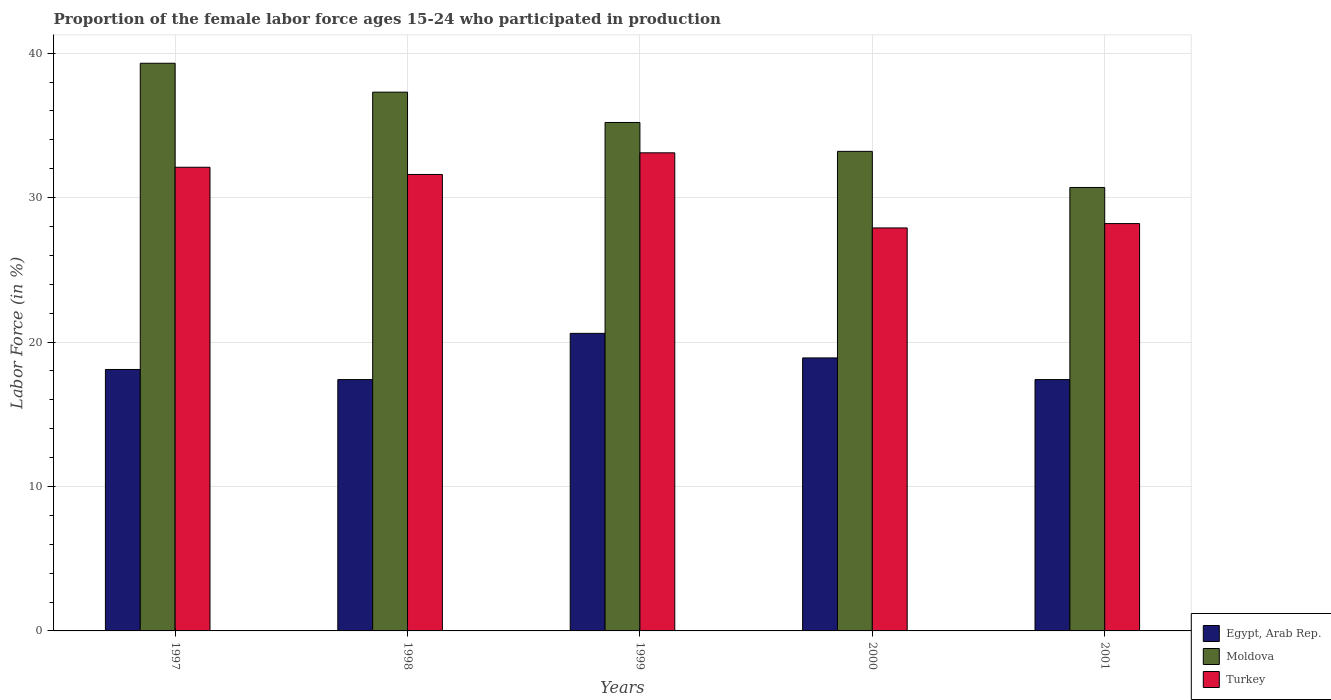How many different coloured bars are there?
Keep it short and to the point. 3. How many groups of bars are there?
Provide a short and direct response. 5. Are the number of bars per tick equal to the number of legend labels?
Your answer should be compact. Yes. How many bars are there on the 3rd tick from the right?
Your answer should be compact. 3. In how many cases, is the number of bars for a given year not equal to the number of legend labels?
Provide a short and direct response. 0. What is the proportion of the female labor force who participated in production in Egypt, Arab Rep. in 2001?
Keep it short and to the point. 17.4. Across all years, what is the maximum proportion of the female labor force who participated in production in Moldova?
Your response must be concise. 39.3. Across all years, what is the minimum proportion of the female labor force who participated in production in Turkey?
Provide a succinct answer. 27.9. In which year was the proportion of the female labor force who participated in production in Turkey maximum?
Offer a very short reply. 1999. What is the total proportion of the female labor force who participated in production in Egypt, Arab Rep. in the graph?
Ensure brevity in your answer.  92.4. What is the difference between the proportion of the female labor force who participated in production in Turkey in 1997 and that in 1998?
Give a very brief answer. 0.5. What is the difference between the proportion of the female labor force who participated in production in Moldova in 1998 and the proportion of the female labor force who participated in production in Turkey in 1999?
Offer a terse response. 4.2. What is the average proportion of the female labor force who participated in production in Moldova per year?
Your answer should be very brief. 35.14. In the year 1998, what is the difference between the proportion of the female labor force who participated in production in Moldova and proportion of the female labor force who participated in production in Egypt, Arab Rep.?
Offer a very short reply. 19.9. In how many years, is the proportion of the female labor force who participated in production in Egypt, Arab Rep. greater than 34 %?
Give a very brief answer. 0. What is the ratio of the proportion of the female labor force who participated in production in Moldova in 1998 to that in 1999?
Make the answer very short. 1.06. Is the difference between the proportion of the female labor force who participated in production in Moldova in 1999 and 2000 greater than the difference between the proportion of the female labor force who participated in production in Egypt, Arab Rep. in 1999 and 2000?
Provide a short and direct response. Yes. What is the difference between the highest and the second highest proportion of the female labor force who participated in production in Egypt, Arab Rep.?
Make the answer very short. 1.7. What is the difference between the highest and the lowest proportion of the female labor force who participated in production in Turkey?
Give a very brief answer. 5.2. In how many years, is the proportion of the female labor force who participated in production in Turkey greater than the average proportion of the female labor force who participated in production in Turkey taken over all years?
Provide a short and direct response. 3. Is the sum of the proportion of the female labor force who participated in production in Turkey in 1997 and 2001 greater than the maximum proportion of the female labor force who participated in production in Moldova across all years?
Provide a short and direct response. Yes. What does the 1st bar from the left in 1999 represents?
Offer a terse response. Egypt, Arab Rep. How many bars are there?
Your response must be concise. 15. What is the difference between two consecutive major ticks on the Y-axis?
Provide a short and direct response. 10. Are the values on the major ticks of Y-axis written in scientific E-notation?
Give a very brief answer. No. Does the graph contain any zero values?
Provide a succinct answer. No. What is the title of the graph?
Offer a very short reply. Proportion of the female labor force ages 15-24 who participated in production. Does "Japan" appear as one of the legend labels in the graph?
Provide a succinct answer. No. What is the label or title of the X-axis?
Offer a very short reply. Years. What is the Labor Force (in %) in Egypt, Arab Rep. in 1997?
Your answer should be very brief. 18.1. What is the Labor Force (in %) of Moldova in 1997?
Provide a short and direct response. 39.3. What is the Labor Force (in %) of Turkey in 1997?
Your response must be concise. 32.1. What is the Labor Force (in %) in Egypt, Arab Rep. in 1998?
Your answer should be compact. 17.4. What is the Labor Force (in %) of Moldova in 1998?
Make the answer very short. 37.3. What is the Labor Force (in %) in Turkey in 1998?
Ensure brevity in your answer.  31.6. What is the Labor Force (in %) of Egypt, Arab Rep. in 1999?
Provide a short and direct response. 20.6. What is the Labor Force (in %) of Moldova in 1999?
Provide a succinct answer. 35.2. What is the Labor Force (in %) in Turkey in 1999?
Keep it short and to the point. 33.1. What is the Labor Force (in %) in Egypt, Arab Rep. in 2000?
Your answer should be compact. 18.9. What is the Labor Force (in %) of Moldova in 2000?
Offer a very short reply. 33.2. What is the Labor Force (in %) in Turkey in 2000?
Make the answer very short. 27.9. What is the Labor Force (in %) of Egypt, Arab Rep. in 2001?
Provide a short and direct response. 17.4. What is the Labor Force (in %) in Moldova in 2001?
Give a very brief answer. 30.7. What is the Labor Force (in %) in Turkey in 2001?
Provide a succinct answer. 28.2. Across all years, what is the maximum Labor Force (in %) in Egypt, Arab Rep.?
Provide a short and direct response. 20.6. Across all years, what is the maximum Labor Force (in %) in Moldova?
Ensure brevity in your answer.  39.3. Across all years, what is the maximum Labor Force (in %) of Turkey?
Give a very brief answer. 33.1. Across all years, what is the minimum Labor Force (in %) of Egypt, Arab Rep.?
Your answer should be very brief. 17.4. Across all years, what is the minimum Labor Force (in %) of Moldova?
Your answer should be very brief. 30.7. Across all years, what is the minimum Labor Force (in %) of Turkey?
Ensure brevity in your answer.  27.9. What is the total Labor Force (in %) in Egypt, Arab Rep. in the graph?
Offer a very short reply. 92.4. What is the total Labor Force (in %) of Moldova in the graph?
Make the answer very short. 175.7. What is the total Labor Force (in %) of Turkey in the graph?
Ensure brevity in your answer.  152.9. What is the difference between the Labor Force (in %) of Egypt, Arab Rep. in 1997 and that in 1998?
Your answer should be very brief. 0.7. What is the difference between the Labor Force (in %) in Moldova in 1997 and that in 1998?
Make the answer very short. 2. What is the difference between the Labor Force (in %) of Turkey in 1997 and that in 1998?
Ensure brevity in your answer.  0.5. What is the difference between the Labor Force (in %) in Moldova in 1997 and that in 1999?
Give a very brief answer. 4.1. What is the difference between the Labor Force (in %) in Moldova in 1997 and that in 2000?
Your response must be concise. 6.1. What is the difference between the Labor Force (in %) in Moldova in 1997 and that in 2001?
Offer a very short reply. 8.6. What is the difference between the Labor Force (in %) of Egypt, Arab Rep. in 1998 and that in 1999?
Provide a succinct answer. -3.2. What is the difference between the Labor Force (in %) of Turkey in 1998 and that in 2000?
Your answer should be compact. 3.7. What is the difference between the Labor Force (in %) of Turkey in 1998 and that in 2001?
Provide a short and direct response. 3.4. What is the difference between the Labor Force (in %) of Egypt, Arab Rep. in 1999 and that in 2000?
Ensure brevity in your answer.  1.7. What is the difference between the Labor Force (in %) in Turkey in 1999 and that in 2000?
Provide a short and direct response. 5.2. What is the difference between the Labor Force (in %) of Egypt, Arab Rep. in 2000 and that in 2001?
Keep it short and to the point. 1.5. What is the difference between the Labor Force (in %) of Turkey in 2000 and that in 2001?
Your response must be concise. -0.3. What is the difference between the Labor Force (in %) of Egypt, Arab Rep. in 1997 and the Labor Force (in %) of Moldova in 1998?
Keep it short and to the point. -19.2. What is the difference between the Labor Force (in %) of Egypt, Arab Rep. in 1997 and the Labor Force (in %) of Turkey in 1998?
Keep it short and to the point. -13.5. What is the difference between the Labor Force (in %) in Egypt, Arab Rep. in 1997 and the Labor Force (in %) in Moldova in 1999?
Ensure brevity in your answer.  -17.1. What is the difference between the Labor Force (in %) of Egypt, Arab Rep. in 1997 and the Labor Force (in %) of Moldova in 2000?
Offer a very short reply. -15.1. What is the difference between the Labor Force (in %) in Egypt, Arab Rep. in 1997 and the Labor Force (in %) in Turkey in 2000?
Make the answer very short. -9.8. What is the difference between the Labor Force (in %) in Egypt, Arab Rep. in 1997 and the Labor Force (in %) in Moldova in 2001?
Your response must be concise. -12.6. What is the difference between the Labor Force (in %) of Egypt, Arab Rep. in 1997 and the Labor Force (in %) of Turkey in 2001?
Keep it short and to the point. -10.1. What is the difference between the Labor Force (in %) in Egypt, Arab Rep. in 1998 and the Labor Force (in %) in Moldova in 1999?
Ensure brevity in your answer.  -17.8. What is the difference between the Labor Force (in %) of Egypt, Arab Rep. in 1998 and the Labor Force (in %) of Turkey in 1999?
Give a very brief answer. -15.7. What is the difference between the Labor Force (in %) in Egypt, Arab Rep. in 1998 and the Labor Force (in %) in Moldova in 2000?
Give a very brief answer. -15.8. What is the difference between the Labor Force (in %) of Moldova in 1998 and the Labor Force (in %) of Turkey in 2000?
Offer a terse response. 9.4. What is the difference between the Labor Force (in %) in Moldova in 1999 and the Labor Force (in %) in Turkey in 2001?
Your response must be concise. 7. What is the difference between the Labor Force (in %) of Egypt, Arab Rep. in 2000 and the Labor Force (in %) of Turkey in 2001?
Keep it short and to the point. -9.3. What is the difference between the Labor Force (in %) in Moldova in 2000 and the Labor Force (in %) in Turkey in 2001?
Keep it short and to the point. 5. What is the average Labor Force (in %) of Egypt, Arab Rep. per year?
Your response must be concise. 18.48. What is the average Labor Force (in %) in Moldova per year?
Offer a very short reply. 35.14. What is the average Labor Force (in %) in Turkey per year?
Your answer should be compact. 30.58. In the year 1997, what is the difference between the Labor Force (in %) of Egypt, Arab Rep. and Labor Force (in %) of Moldova?
Offer a terse response. -21.2. In the year 1997, what is the difference between the Labor Force (in %) in Egypt, Arab Rep. and Labor Force (in %) in Turkey?
Your answer should be compact. -14. In the year 1997, what is the difference between the Labor Force (in %) of Moldova and Labor Force (in %) of Turkey?
Give a very brief answer. 7.2. In the year 1998, what is the difference between the Labor Force (in %) of Egypt, Arab Rep. and Labor Force (in %) of Moldova?
Provide a succinct answer. -19.9. In the year 1999, what is the difference between the Labor Force (in %) in Egypt, Arab Rep. and Labor Force (in %) in Moldova?
Keep it short and to the point. -14.6. In the year 1999, what is the difference between the Labor Force (in %) of Egypt, Arab Rep. and Labor Force (in %) of Turkey?
Provide a short and direct response. -12.5. In the year 2000, what is the difference between the Labor Force (in %) in Egypt, Arab Rep. and Labor Force (in %) in Moldova?
Your answer should be compact. -14.3. In the year 2000, what is the difference between the Labor Force (in %) of Egypt, Arab Rep. and Labor Force (in %) of Turkey?
Provide a short and direct response. -9. In the year 2000, what is the difference between the Labor Force (in %) of Moldova and Labor Force (in %) of Turkey?
Make the answer very short. 5.3. In the year 2001, what is the difference between the Labor Force (in %) of Egypt, Arab Rep. and Labor Force (in %) of Moldova?
Keep it short and to the point. -13.3. What is the ratio of the Labor Force (in %) in Egypt, Arab Rep. in 1997 to that in 1998?
Provide a succinct answer. 1.04. What is the ratio of the Labor Force (in %) in Moldova in 1997 to that in 1998?
Provide a short and direct response. 1.05. What is the ratio of the Labor Force (in %) of Turkey in 1997 to that in 1998?
Provide a short and direct response. 1.02. What is the ratio of the Labor Force (in %) of Egypt, Arab Rep. in 1997 to that in 1999?
Give a very brief answer. 0.88. What is the ratio of the Labor Force (in %) of Moldova in 1997 to that in 1999?
Provide a short and direct response. 1.12. What is the ratio of the Labor Force (in %) of Turkey in 1997 to that in 1999?
Your answer should be very brief. 0.97. What is the ratio of the Labor Force (in %) in Egypt, Arab Rep. in 1997 to that in 2000?
Make the answer very short. 0.96. What is the ratio of the Labor Force (in %) of Moldova in 1997 to that in 2000?
Your answer should be compact. 1.18. What is the ratio of the Labor Force (in %) in Turkey in 1997 to that in 2000?
Provide a succinct answer. 1.15. What is the ratio of the Labor Force (in %) of Egypt, Arab Rep. in 1997 to that in 2001?
Your answer should be very brief. 1.04. What is the ratio of the Labor Force (in %) in Moldova in 1997 to that in 2001?
Your answer should be very brief. 1.28. What is the ratio of the Labor Force (in %) in Turkey in 1997 to that in 2001?
Offer a terse response. 1.14. What is the ratio of the Labor Force (in %) in Egypt, Arab Rep. in 1998 to that in 1999?
Provide a short and direct response. 0.84. What is the ratio of the Labor Force (in %) in Moldova in 1998 to that in 1999?
Offer a very short reply. 1.06. What is the ratio of the Labor Force (in %) of Turkey in 1998 to that in 1999?
Ensure brevity in your answer.  0.95. What is the ratio of the Labor Force (in %) of Egypt, Arab Rep. in 1998 to that in 2000?
Your answer should be very brief. 0.92. What is the ratio of the Labor Force (in %) of Moldova in 1998 to that in 2000?
Offer a very short reply. 1.12. What is the ratio of the Labor Force (in %) of Turkey in 1998 to that in 2000?
Provide a succinct answer. 1.13. What is the ratio of the Labor Force (in %) in Moldova in 1998 to that in 2001?
Offer a terse response. 1.22. What is the ratio of the Labor Force (in %) of Turkey in 1998 to that in 2001?
Provide a succinct answer. 1.12. What is the ratio of the Labor Force (in %) in Egypt, Arab Rep. in 1999 to that in 2000?
Give a very brief answer. 1.09. What is the ratio of the Labor Force (in %) of Moldova in 1999 to that in 2000?
Ensure brevity in your answer.  1.06. What is the ratio of the Labor Force (in %) of Turkey in 1999 to that in 2000?
Keep it short and to the point. 1.19. What is the ratio of the Labor Force (in %) in Egypt, Arab Rep. in 1999 to that in 2001?
Keep it short and to the point. 1.18. What is the ratio of the Labor Force (in %) of Moldova in 1999 to that in 2001?
Your response must be concise. 1.15. What is the ratio of the Labor Force (in %) of Turkey in 1999 to that in 2001?
Your response must be concise. 1.17. What is the ratio of the Labor Force (in %) of Egypt, Arab Rep. in 2000 to that in 2001?
Your response must be concise. 1.09. What is the ratio of the Labor Force (in %) of Moldova in 2000 to that in 2001?
Make the answer very short. 1.08. What is the ratio of the Labor Force (in %) in Turkey in 2000 to that in 2001?
Your answer should be very brief. 0.99. What is the difference between the highest and the second highest Labor Force (in %) of Egypt, Arab Rep.?
Provide a succinct answer. 1.7. What is the difference between the highest and the lowest Labor Force (in %) of Egypt, Arab Rep.?
Provide a short and direct response. 3.2. What is the difference between the highest and the lowest Labor Force (in %) of Turkey?
Make the answer very short. 5.2. 